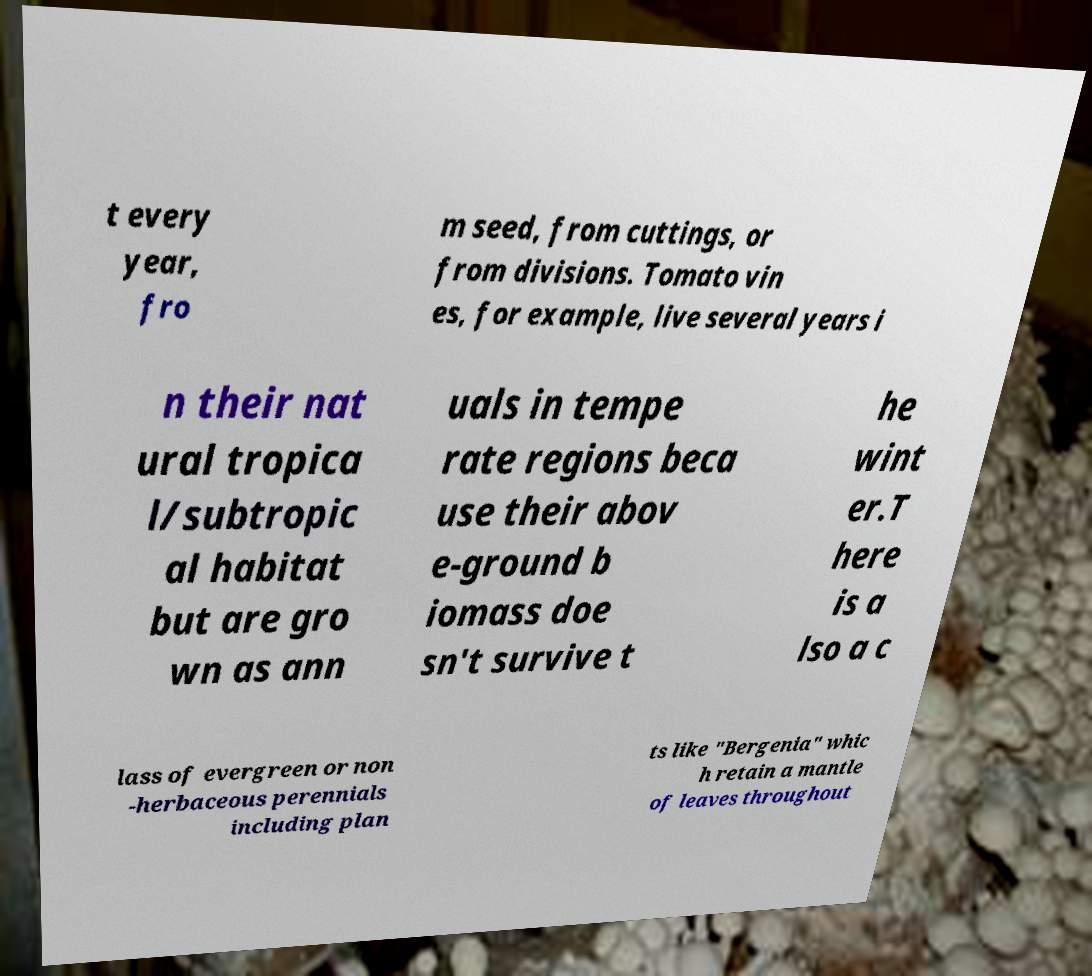Can you accurately transcribe the text from the provided image for me? t every year, fro m seed, from cuttings, or from divisions. Tomato vin es, for example, live several years i n their nat ural tropica l/subtropic al habitat but are gro wn as ann uals in tempe rate regions beca use their abov e-ground b iomass doe sn't survive t he wint er.T here is a lso a c lass of evergreen or non -herbaceous perennials including plan ts like "Bergenia" whic h retain a mantle of leaves throughout 